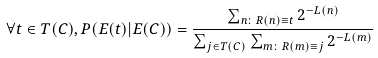Convert formula to latex. <formula><loc_0><loc_0><loc_500><loc_500>\forall t \in T ( C ) , P ( E ( t ) | E ( C ) ) = { \frac { \sum _ { n \colon R ( n ) \equiv t } 2 ^ { - L ( n ) } } { \sum _ { j \in T ( C ) } \sum _ { m \colon R ( m ) \equiv j } 2 ^ { - L ( m ) } } }</formula> 